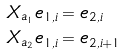Convert formula to latex. <formula><loc_0><loc_0><loc_500><loc_500>X _ { a _ { 1 } } e _ { 1 , i } & = e _ { 2 , i } \\ X _ { a _ { 2 } } e _ { 1 , i } & = e _ { 2 , i + 1 }</formula> 